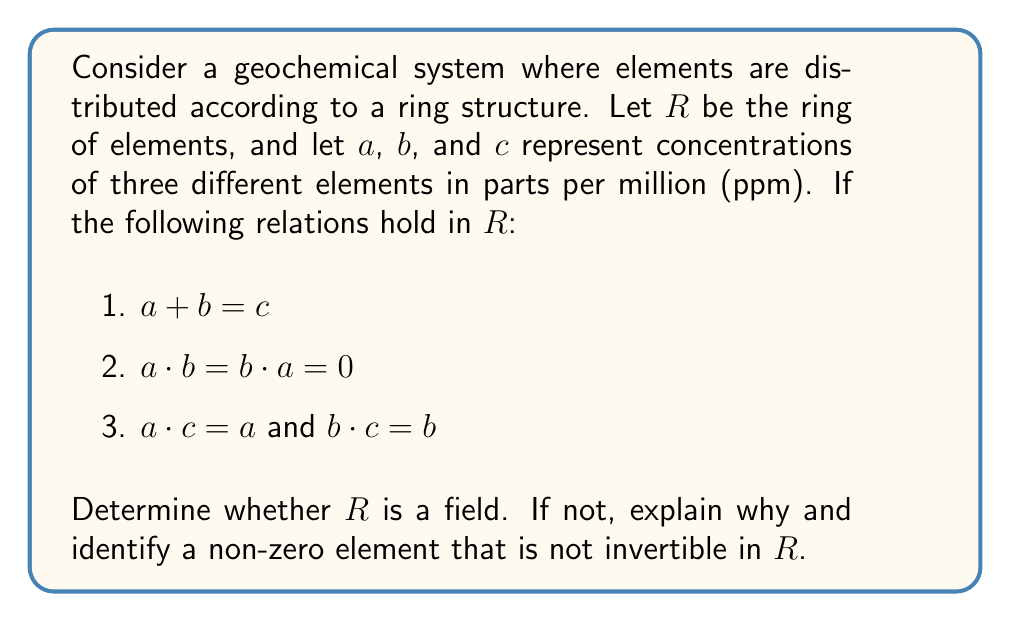Show me your answer to this math problem. To determine if $R$ is a field, we need to check if it satisfies all the field axioms. Let's analyze the given information:

1. $(R, +)$ forms an abelian group:
   - Closure and associativity are assumed.
   - The identity element for addition is 0.
   - Commutativity is satisfied (not explicitly stated but assumed for a ring).
   - Inverse elements exist for addition (assumed for a ring).

2. $(R, \cdot)$ forms a monoid:
   - Closure and associativity are assumed.
   - The identity element for multiplication is $c$, since $a \cdot c = a$ and $b \cdot c = b$.

3. Multiplication is distributive over addition (assumed for a ring).

However, for $R$ to be a field, every non-zero element must have a multiplicative inverse. Let's check this condition:

- For element $a$:
  $a \cdot b = 0$, but $a \neq 0$ and $b \neq 0$ (since $a + b = c \neq 0$).
  This means $a$ is a zero divisor and cannot have a multiplicative inverse.

- Similarly, for element $b$:
  $b \cdot a = 0$, but $b \neq 0$ and $a \neq 0$.
  This means $b$ is also a zero divisor and cannot have a multiplicative inverse.

The presence of zero divisors (non-zero elements whose product is zero) in a ring implies that the ring is not a field. Therefore, $R$ is not a field.

A non-zero element that is not invertible in $R$ is $a$ (or $b$). We can prove this:

Suppose $a$ has an inverse $x$. Then:
$a \cdot x = x \cdot a = c$ (since $c$ is the multiplicative identity)

But we know that $a \cdot b = 0$, so:
$0 = (a \cdot b) \cdot x = a \cdot (b \cdot x) = a \cdot b = 0$

This contradicts our assumption that $x$ is the inverse of $a$. Therefore, $a$ does not have a multiplicative inverse in $R$.
Answer: $R$ is not a field. A non-zero element that is not invertible in $R$ is $a$ (or $b$). 